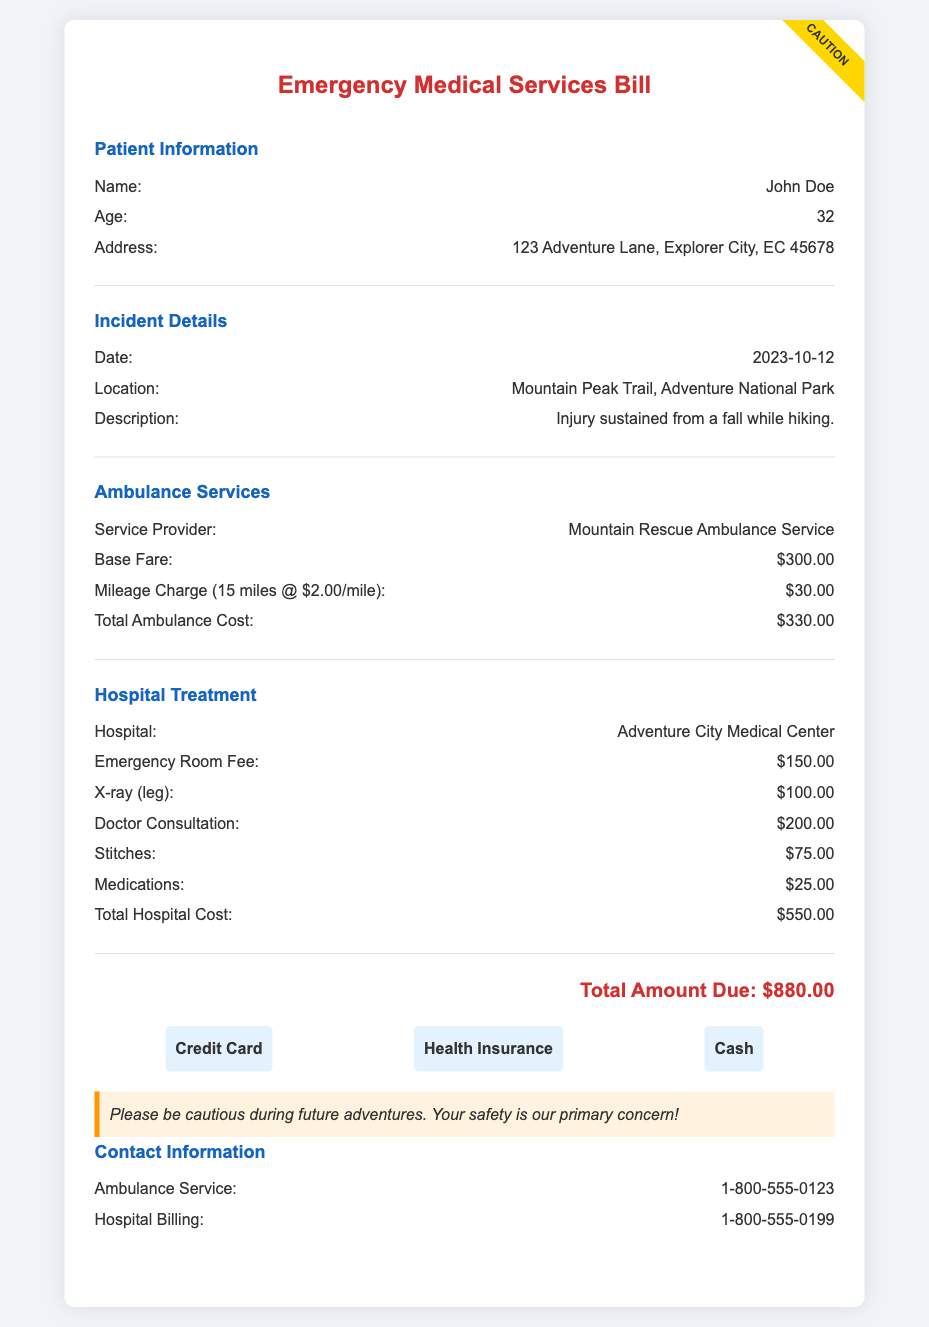What is the patient's name? The document specifies the name of the patient as John Doe.
Answer: John Doe What is the total amount due? The total amount due is calculated from the ambulance and hospital costs, which sum up to $880.00.
Answer: $880.00 What date did the incident occur? The date of the incident is listed under the incident details as October 12, 2023.
Answer: 2023-10-12 What is the base fare for the ambulance service? The base fare for the ambulance service is explicitly mentioned as $300.00.
Answer: $300.00 What type of injury did the patient sustain? The description of the incident indicates the patient sustained an injury from a fall while hiking.
Answer: Injury from a fall while hiking What is the cost of the doctor consultation? The cost for doctor consultation is provided in the hospital treatment section as $200.00.
Answer: $200.00 How many miles was the ambulance charged for? The document states a mileage charge for 15 miles at a rate of $2.00/mile.
Answer: 15 miles What services are offered as payment options? The payment options provided in the document include Credit Card, Health Insurance, and Cash.
Answer: Credit Card, Health Insurance, Cash Who can be contacted for hospital billing inquiries? The document provides a phone number for hospital billing inquiries, which is 1-800-555-0199.
Answer: 1-800-555-0199 